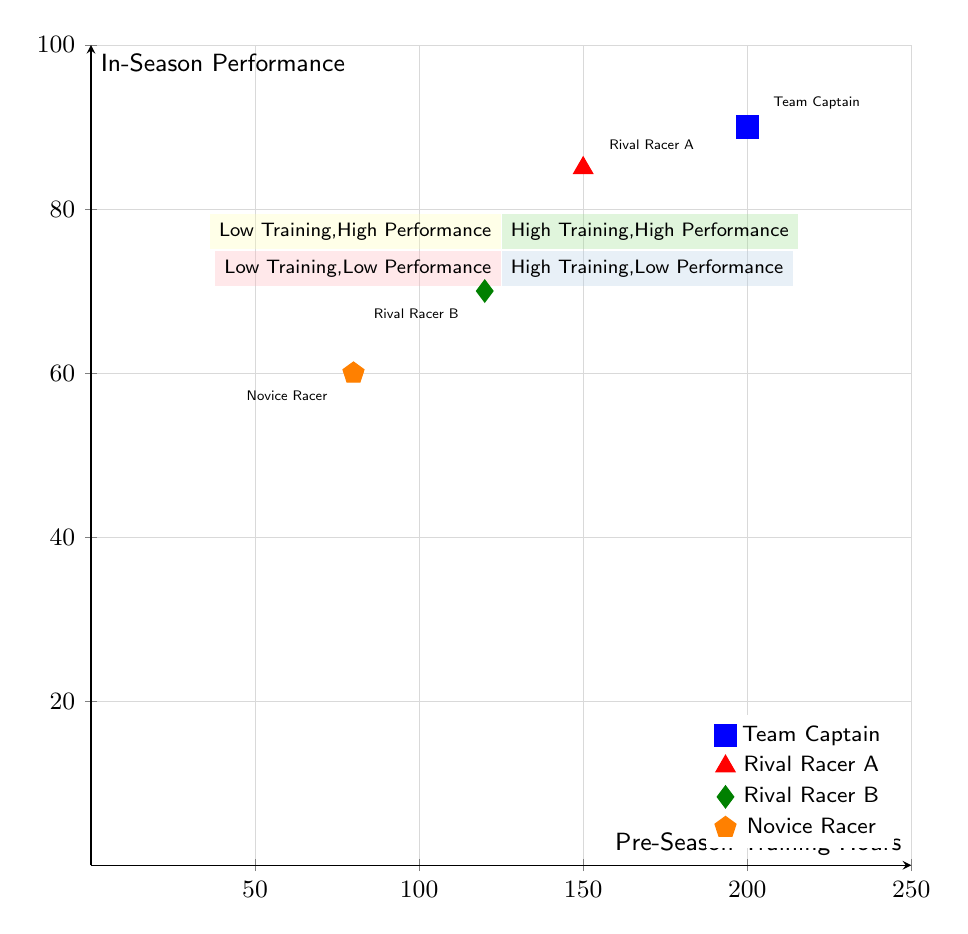What quadrant is the Team Captain located in? The Team Captain has high training hours (200) and high performance (90), which places them in Quadrant 1, defined as "High Training Hours, High Performance."
Answer: Quadrant 1 How many data points are in the diagram? There are four data points representing different racers: Team Captain, Rival Racer A, Rival Racer B, and Novice Racer.
Answer: 4 What is the performance score of Rival Racer B? The performance score of Rival Racer B is 70, as indicated by their position on the y-axis.
Answer: 70 What is the training hour count for the Novice Racer? The Novice Racer has a training hour count of 80, shown at their position along the x-axis.
Answer: 80 Which racer has the highest performance score? The Team Captain has the highest performance score of 90, the highest value on the y-axis among all data points.
Answer: Team Captain Why does Rival Racer A have less training hours but higher performance than Rival Racer B? Rival Racer A has 150 training hours and a performance score of 85, while Rival Racer B has only 120 training hours and a score of 70. This indicates that Rival Racer A's training hours translate more effectively into performance compared to Rival Racer B.
Answer: More effective training Which quadrant is characterized by low training hours but high performance? Quadrant 2 is characterized by low training hours and high performance, indicating that there are racers who achieve good results without extensive training.
Answer: Quadrant 2 Considering all racers, how many have performance scores below 70? Only one racer, the Novice Racer with a performance score of 60, has a score below 70, indicating lower in-season performance.
Answer: 1 What is the training hour count for the racer with the lowest performance score? The Novice Racer has the lowest performance score of 60 and corresponds to 80 training hours, as noted in their position along the axes.
Answer: 80 